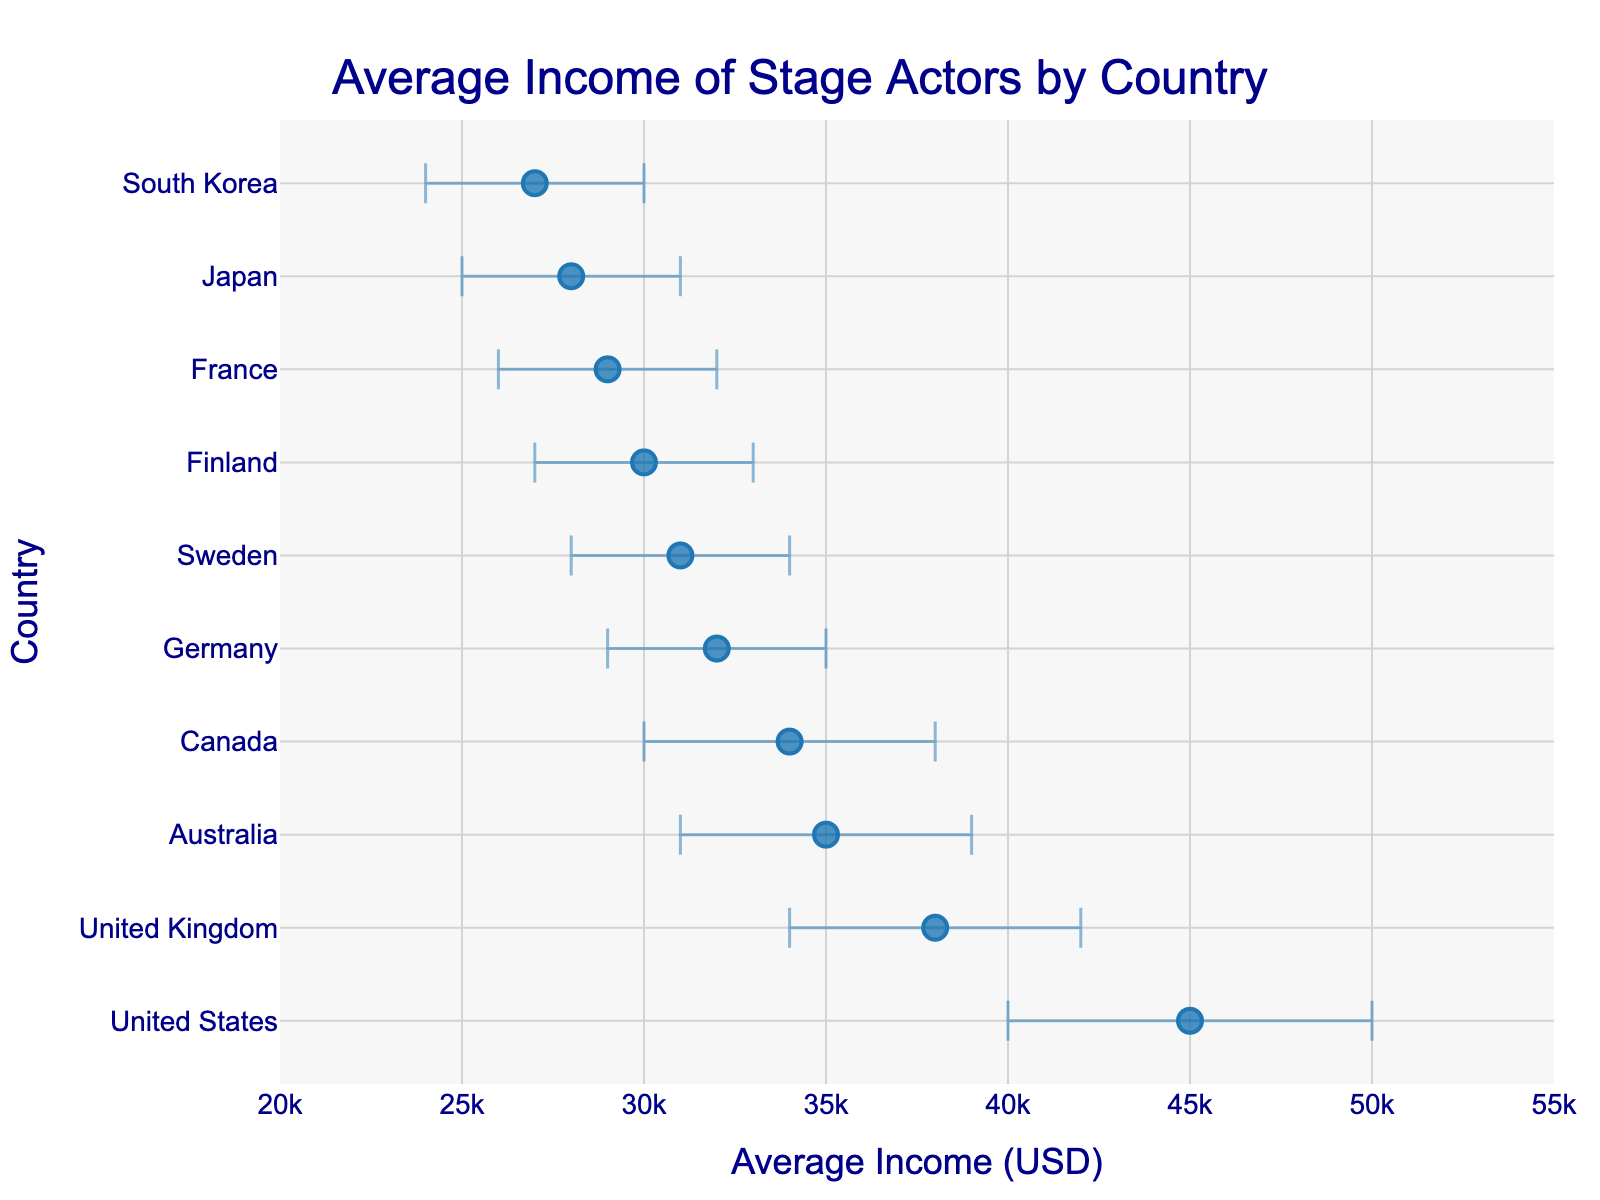What is the title of the plot? The title is located at the top center of the plot and is written in a larger font size than other texts.
Answer: Average Income of Stage Actors by Country What is the average income of stage actors in Finland? Find Finland on the y-axis and read the corresponding value on the x-axis from the dot.
Answer: 30000 USD Which country has the highest average income for stage actors? Identify the country with the dot farthest to the right on the x-axis (the highest value).
Answer: United States What is the confidence interval range for stage actors' income in France? Locate France on the y-axis and check the range between the lower and upper ends of the error bar.
Answer: 26000 to 32000 USD How much higher is the average income in the United States compared to Finland? Subtract the average income of Finland from that of the United States.
Answer: 15000 USD Which country has the smallest confidence interval range? Find the country where the difference between the upper and lower confidence intervals is the smallest.
Answer: United Kingdom Is the average income of stage actors in Germany higher or lower than in Canada? Compare the positions of Germany and Canada on the x-axis.
Answer: Lower Which countries have an average income above 35000 USD? Identify the countries with dots located to the right of the 35000 USD mark on the x-axis.
Answer: United States, United Kingdom, Australia What is the average of the average incomes of stage actors in Sweden and Japan? Add the average incomes of Sweden and Japan, then divide by 2.
Answer: 29500 USD 